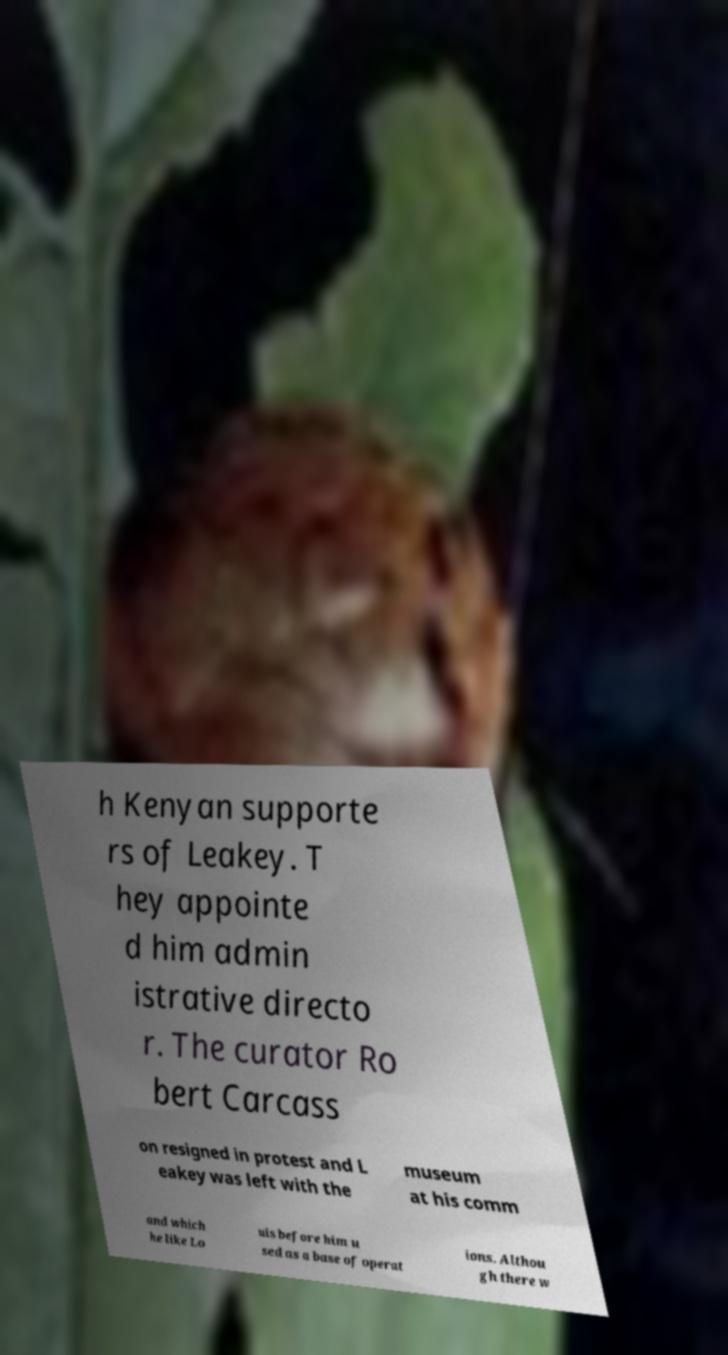What messages or text are displayed in this image? I need them in a readable, typed format. h Kenyan supporte rs of Leakey. T hey appointe d him admin istrative directo r. The curator Ro bert Carcass on resigned in protest and L eakey was left with the museum at his comm and which he like Lo uis before him u sed as a base of operat ions. Althou gh there w 